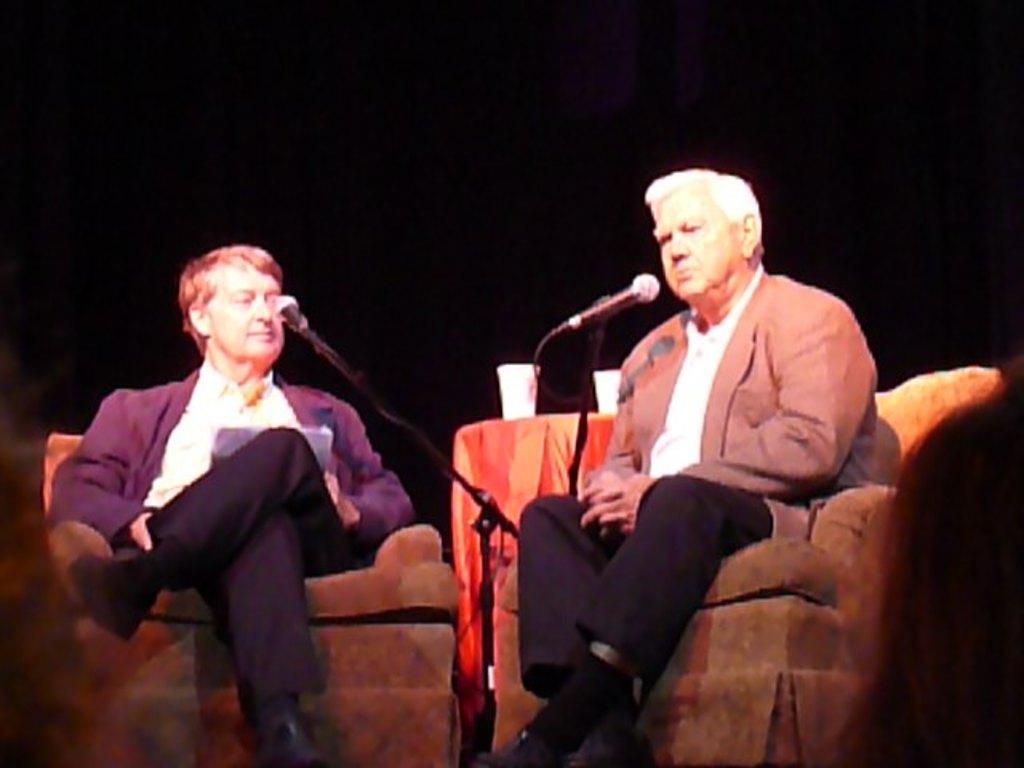Can you describe this image briefly? There are two men sitting on chairs. In front of them there are mics with mic stands. In the back there is a table with tablecloth. On that there are cups. In the background it is dark. 